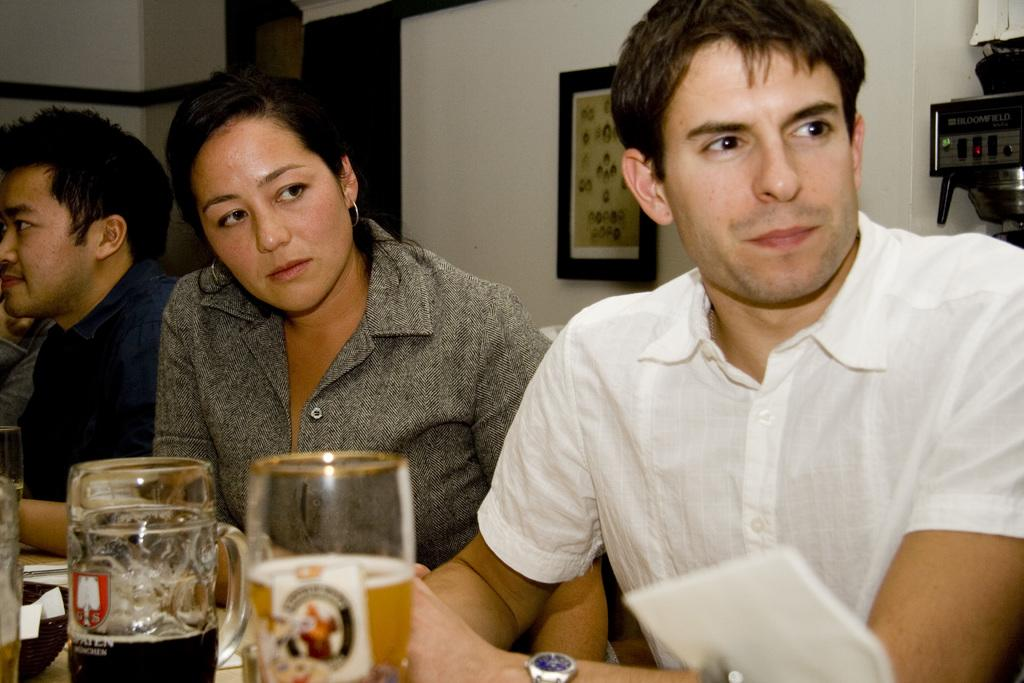Who or what is present in the image? There are people in the image. What are the glasses in the image containing? The glasses in the image contain liquids. Can you describe the objects at the bottom of the image? There are objects at the bottom of the image, but their specific details are not mentioned in the provided facts. What can be seen in the background of the image? There is a wall, a photo frame, and a machine in the background of the image. What type of mitten is being used to create a wave in the image? There is no mitten or wave present in the image. How many rings can be seen on the fingers of the people in the image? The provided facts do not mention any rings on the people's fingers in the image. 